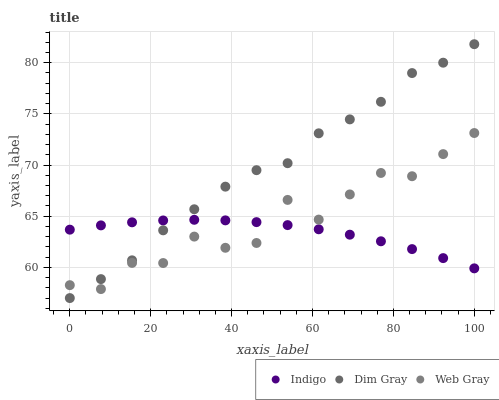Does Indigo have the minimum area under the curve?
Answer yes or no. Yes. Does Dim Gray have the maximum area under the curve?
Answer yes or no. Yes. Does Dim Gray have the minimum area under the curve?
Answer yes or no. No. Does Indigo have the maximum area under the curve?
Answer yes or no. No. Is Indigo the smoothest?
Answer yes or no. Yes. Is Web Gray the roughest?
Answer yes or no. Yes. Is Dim Gray the smoothest?
Answer yes or no. No. Is Dim Gray the roughest?
Answer yes or no. No. Does Dim Gray have the lowest value?
Answer yes or no. Yes. Does Indigo have the lowest value?
Answer yes or no. No. Does Dim Gray have the highest value?
Answer yes or no. Yes. Does Indigo have the highest value?
Answer yes or no. No. Does Indigo intersect Web Gray?
Answer yes or no. Yes. Is Indigo less than Web Gray?
Answer yes or no. No. Is Indigo greater than Web Gray?
Answer yes or no. No. 